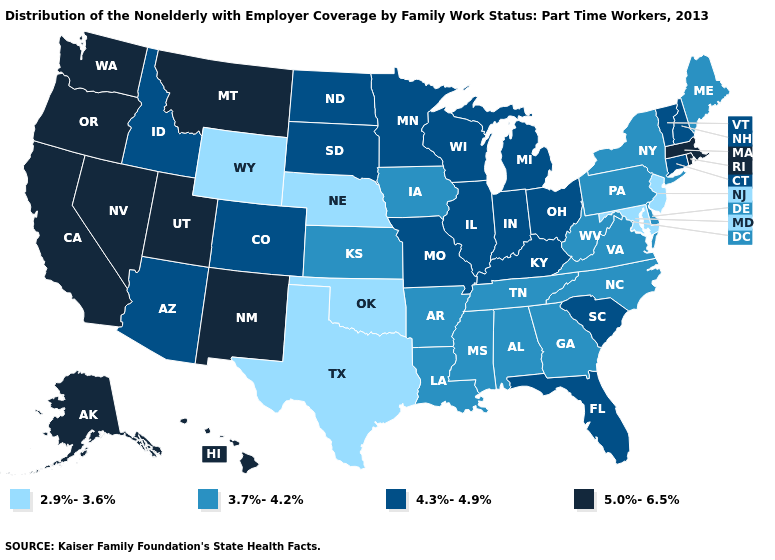What is the highest value in states that border North Dakota?
Short answer required. 5.0%-6.5%. Does Texas have the lowest value in the South?
Keep it brief. Yes. Does Wyoming have the lowest value in the West?
Answer briefly. Yes. Is the legend a continuous bar?
Short answer required. No. Among the states that border Arizona , which have the highest value?
Be succinct. California, Nevada, New Mexico, Utah. What is the highest value in states that border Maryland?
Short answer required. 3.7%-4.2%. What is the value of Missouri?
Be succinct. 4.3%-4.9%. What is the value of West Virginia?
Keep it brief. 3.7%-4.2%. Does West Virginia have the highest value in the USA?
Quick response, please. No. Name the states that have a value in the range 5.0%-6.5%?
Quick response, please. Alaska, California, Hawaii, Massachusetts, Montana, Nevada, New Mexico, Oregon, Rhode Island, Utah, Washington. Name the states that have a value in the range 5.0%-6.5%?
Be succinct. Alaska, California, Hawaii, Massachusetts, Montana, Nevada, New Mexico, Oregon, Rhode Island, Utah, Washington. What is the highest value in the USA?
Write a very short answer. 5.0%-6.5%. Among the states that border Ohio , does Pennsylvania have the lowest value?
Concise answer only. Yes. What is the lowest value in states that border Pennsylvania?
Be succinct. 2.9%-3.6%. Name the states that have a value in the range 5.0%-6.5%?
Answer briefly. Alaska, California, Hawaii, Massachusetts, Montana, Nevada, New Mexico, Oregon, Rhode Island, Utah, Washington. 